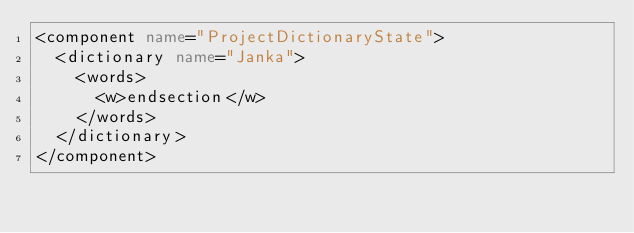Convert code to text. <code><loc_0><loc_0><loc_500><loc_500><_XML_><component name="ProjectDictionaryState">
  <dictionary name="Janka">
    <words>
      <w>endsection</w>
    </words>
  </dictionary>
</component></code> 